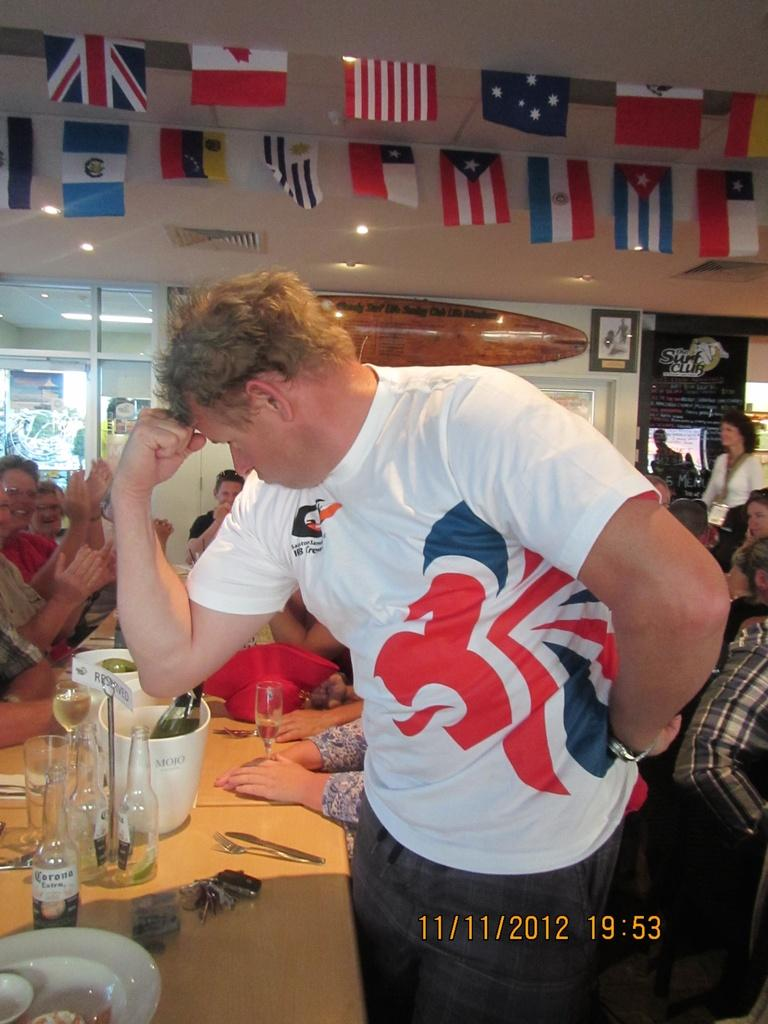<image>
Render a clear and concise summary of the photo. A man in a white, red and blue t-shirt strikes a heroic pose at the Surf Club. 